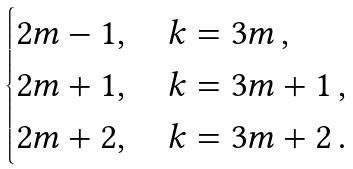Convert formula to latex. <formula><loc_0><loc_0><loc_500><loc_500>\begin{cases} 2 m - 1 , \quad k = 3 m \, , \\ 2 m + 1 , \quad k = 3 m + 1 \, , \\ 2 m + 2 , \quad k = 3 m + 2 \, . \end{cases}</formula> 